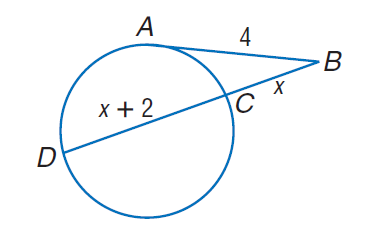Answer the mathemtical geometry problem and directly provide the correct option letter.
Question: Find x. Assume that segments that appear to be tangent are tangent.
Choices: A: 2 B: 2.37 C: 4 D: 4.37 B 